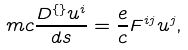<formula> <loc_0><loc_0><loc_500><loc_500>m c \frac { D ^ { \{ \} } u ^ { i } } { d s } = \frac { e } { c } F ^ { i j } u ^ { j } ,</formula> 